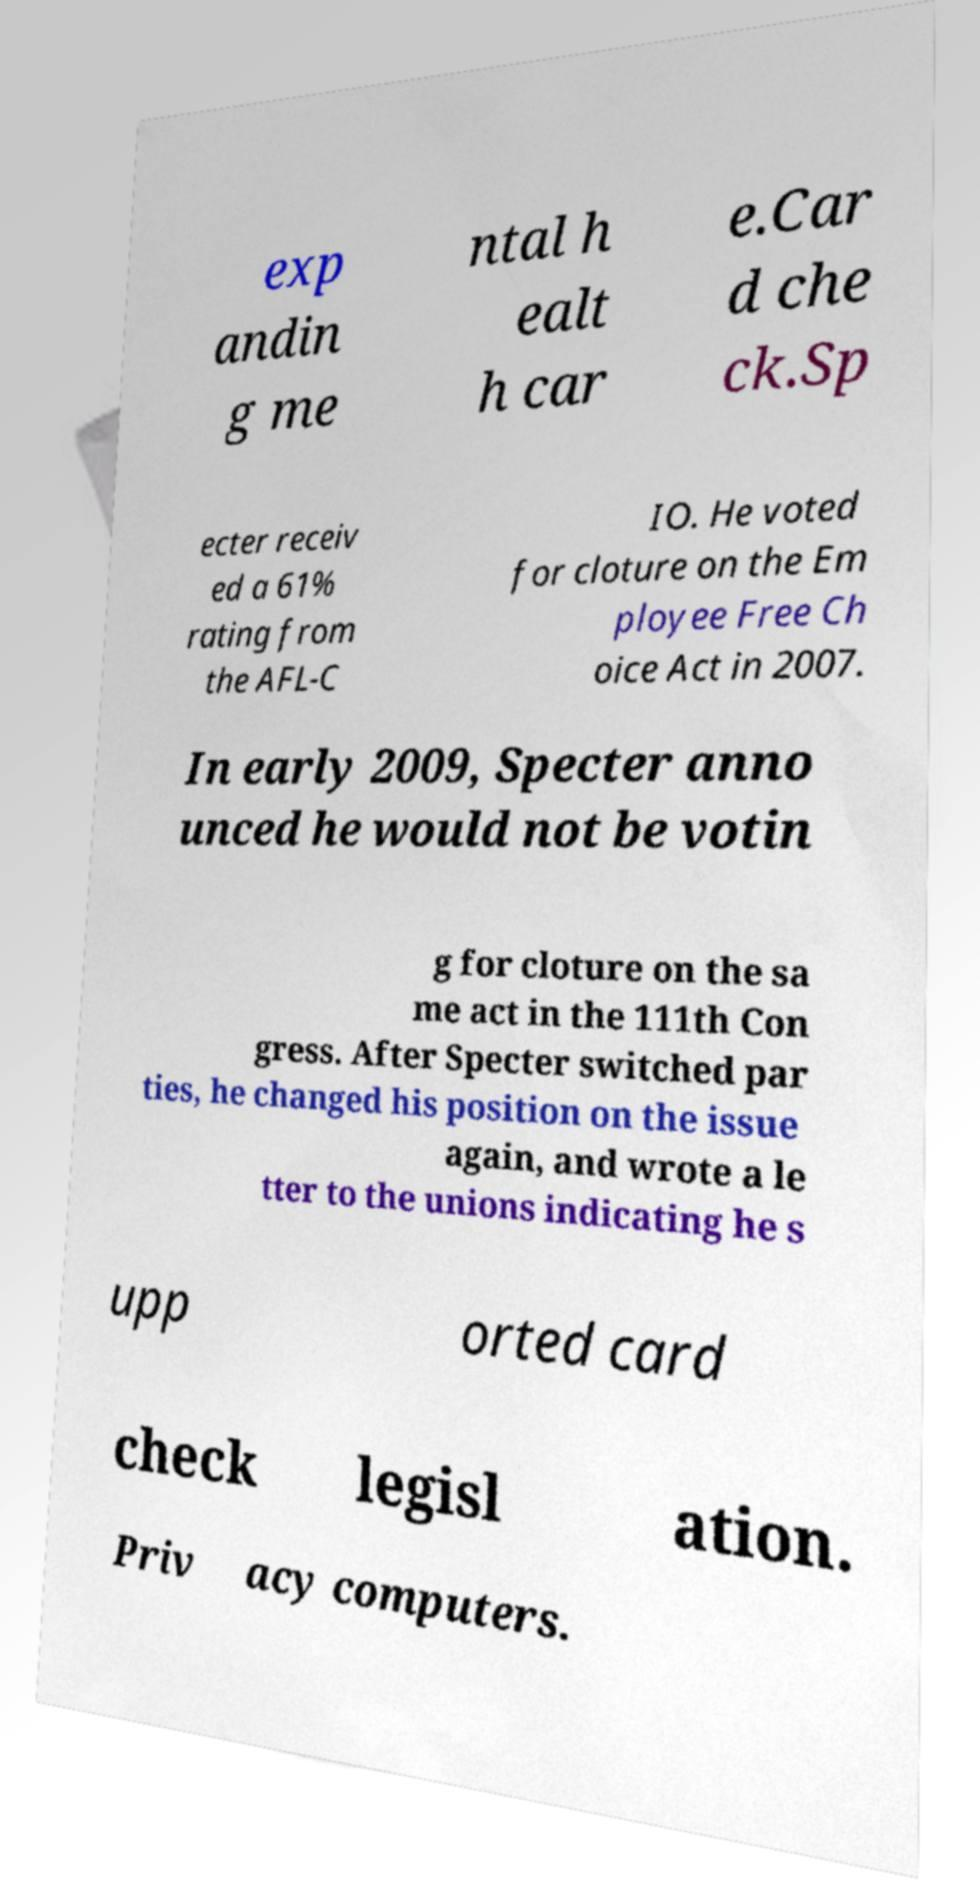Please read and relay the text visible in this image. What does it say? exp andin g me ntal h ealt h car e.Car d che ck.Sp ecter receiv ed a 61% rating from the AFL-C IO. He voted for cloture on the Em ployee Free Ch oice Act in 2007. In early 2009, Specter anno unced he would not be votin g for cloture on the sa me act in the 111th Con gress. After Specter switched par ties, he changed his position on the issue again, and wrote a le tter to the unions indicating he s upp orted card check legisl ation. Priv acy computers. 